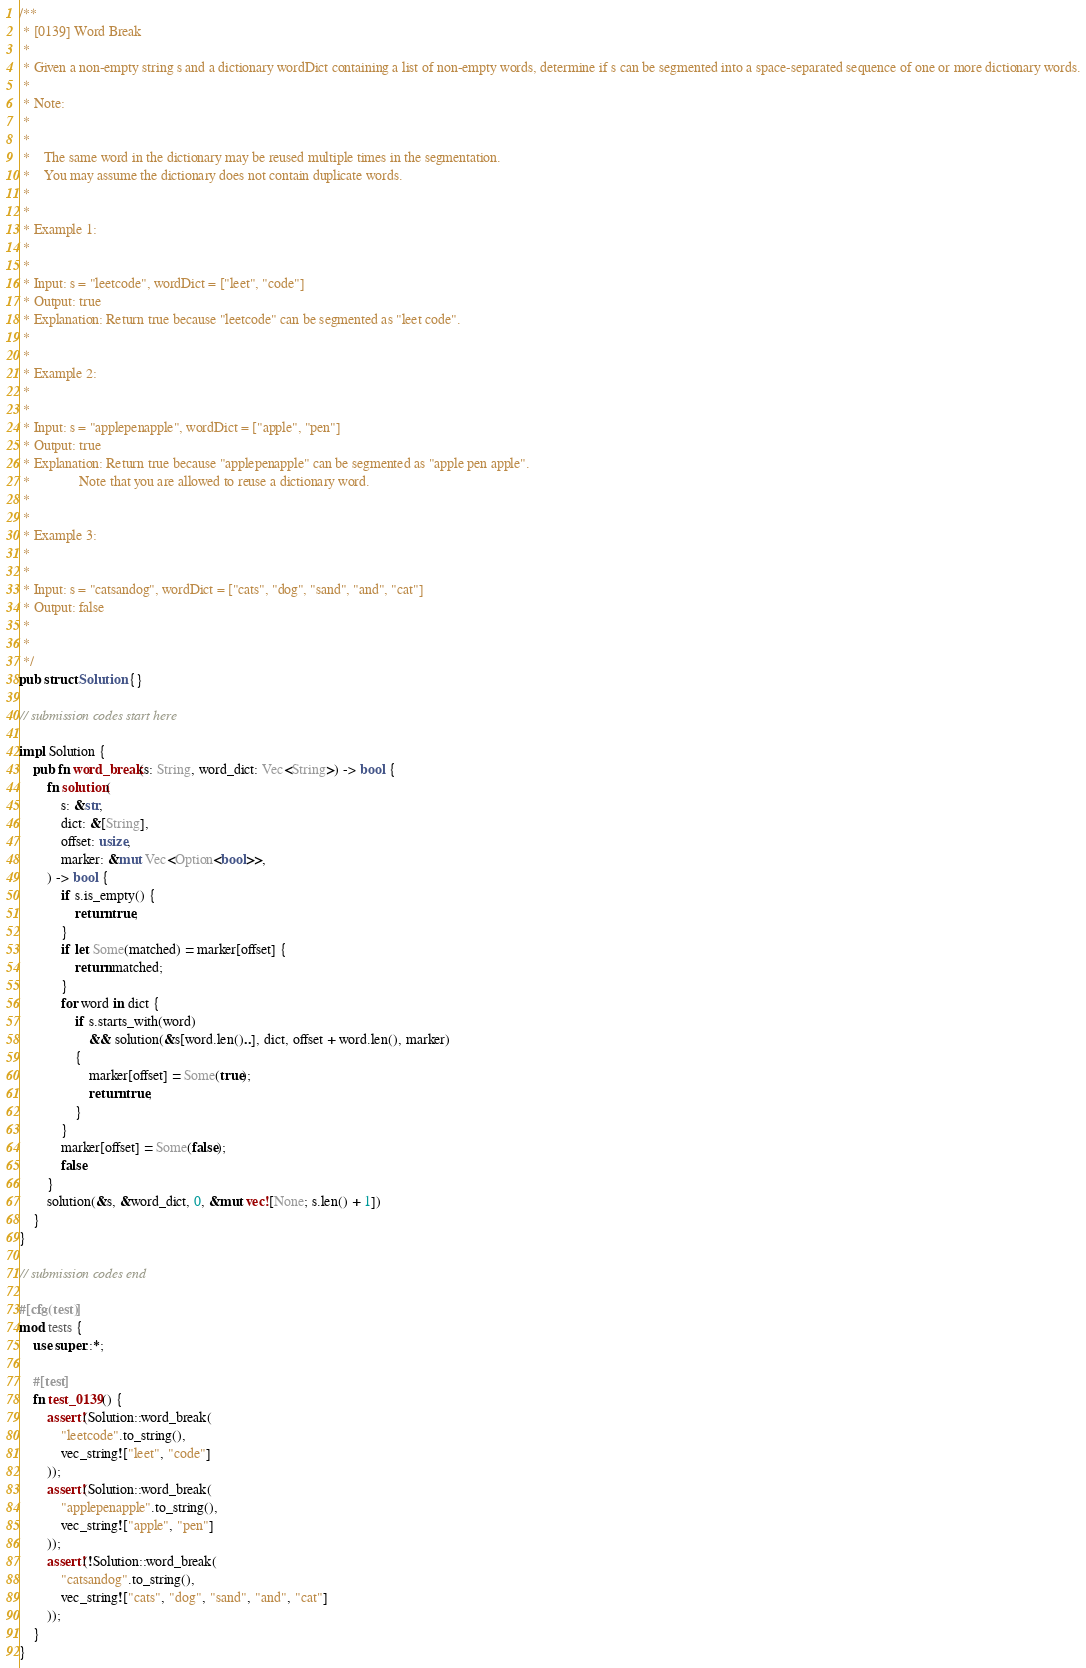Convert code to text. <code><loc_0><loc_0><loc_500><loc_500><_Rust_>/**
 * [0139] Word Break
 *
 * Given a non-empty string s and a dictionary wordDict containing a list of non-empty words, determine if s can be segmented into a space-separated sequence of one or more dictionary words.
 *
 * Note:
 *
 *
 * 	The same word in the dictionary may be reused multiple times in the segmentation.
 * 	You may assume the dictionary does not contain duplicate words.
 *
 *
 * Example 1:
 *
 *
 * Input: s = "leetcode", wordDict = ["leet", "code"]
 * Output: true
 * Explanation: Return true because "leetcode" can be segmented as "leet code".
 *
 *
 * Example 2:
 *
 *
 * Input: s = "applepenapple", wordDict = ["apple", "pen"]
 * Output: true
 * Explanation: Return true because "applepenapple" can be segmented as "apple pen apple".
 *              Note that you are allowed to reuse a dictionary word.
 *
 *
 * Example 3:
 *
 *
 * Input: s = "catsandog", wordDict = ["cats", "dog", "sand", "and", "cat"]
 * Output: false
 *
 *
 */
pub struct Solution {}

// submission codes start here

impl Solution {
    pub fn word_break(s: String, word_dict: Vec<String>) -> bool {
        fn solution(
            s: &str,
            dict: &[String],
            offset: usize,
            marker: &mut Vec<Option<bool>>,
        ) -> bool {
            if s.is_empty() {
                return true;
            }
            if let Some(matched) = marker[offset] {
                return matched;
            }
            for word in dict {
                if s.starts_with(word)
                    && solution(&s[word.len()..], dict, offset + word.len(), marker)
                {
                    marker[offset] = Some(true);
                    return true;
                }
            }
            marker[offset] = Some(false);
            false
        }
        solution(&s, &word_dict, 0, &mut vec![None; s.len() + 1])
    }
}

// submission codes end

#[cfg(test)]
mod tests {
    use super::*;

    #[test]
    fn test_0139() {
        assert!(Solution::word_break(
            "leetcode".to_string(),
            vec_string!["leet", "code"]
        ));
        assert!(Solution::word_break(
            "applepenapple".to_string(),
            vec_string!["apple", "pen"]
        ));
        assert!(!Solution::word_break(
            "catsandog".to_string(),
            vec_string!["cats", "dog", "sand", "and", "cat"]
        ));
    }
}
</code> 